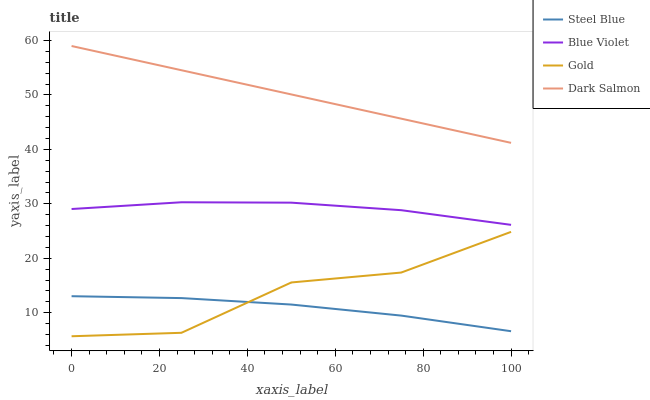Does Blue Violet have the minimum area under the curve?
Answer yes or no. No. Does Blue Violet have the maximum area under the curve?
Answer yes or no. No. Is Steel Blue the smoothest?
Answer yes or no. No. Is Steel Blue the roughest?
Answer yes or no. No. Does Steel Blue have the lowest value?
Answer yes or no. No. Does Blue Violet have the highest value?
Answer yes or no. No. Is Steel Blue less than Blue Violet?
Answer yes or no. Yes. Is Blue Violet greater than Gold?
Answer yes or no. Yes. Does Steel Blue intersect Blue Violet?
Answer yes or no. No. 